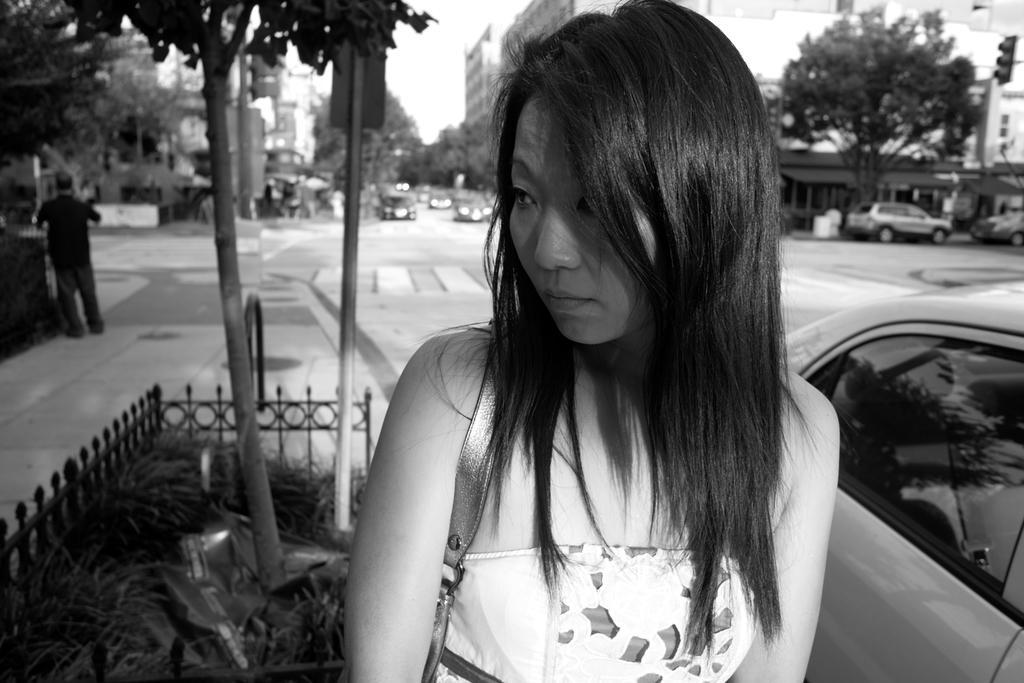Please provide a concise description of this image. As we can see in the image there are trees, buildings, vehicles, a woman standing in the front and wearing white color dress. At the top there is sky. 